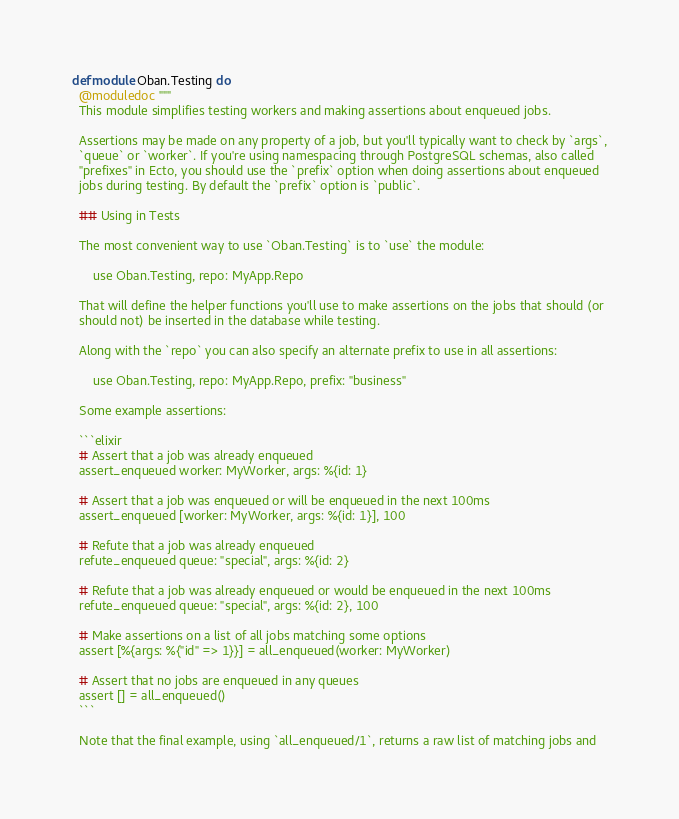Convert code to text. <code><loc_0><loc_0><loc_500><loc_500><_Elixir_>defmodule Oban.Testing do
  @moduledoc """
  This module simplifies testing workers and making assertions about enqueued jobs.

  Assertions may be made on any property of a job, but you'll typically want to check by `args`,
  `queue` or `worker`. If you're using namespacing through PostgreSQL schemas, also called
  "prefixes" in Ecto, you should use the `prefix` option when doing assertions about enqueued
  jobs during testing. By default the `prefix` option is `public`.

  ## Using in Tests

  The most convenient way to use `Oban.Testing` is to `use` the module:

      use Oban.Testing, repo: MyApp.Repo

  That will define the helper functions you'll use to make assertions on the jobs that should (or
  should not) be inserted in the database while testing.

  Along with the `repo` you can also specify an alternate prefix to use in all assertions:

      use Oban.Testing, repo: MyApp.Repo, prefix: "business"

  Some example assertions:

  ```elixir
  # Assert that a job was already enqueued
  assert_enqueued worker: MyWorker, args: %{id: 1}

  # Assert that a job was enqueued or will be enqueued in the next 100ms
  assert_enqueued [worker: MyWorker, args: %{id: 1}], 100

  # Refute that a job was already enqueued
  refute_enqueued queue: "special", args: %{id: 2}

  # Refute that a job was already enqueued or would be enqueued in the next 100ms
  refute_enqueued queue: "special", args: %{id: 2}, 100

  # Make assertions on a list of all jobs matching some options
  assert [%{args: %{"id" => 1}}] = all_enqueued(worker: MyWorker)

  # Assert that no jobs are enqueued in any queues
  assert [] = all_enqueued()
  ```

  Note that the final example, using `all_enqueued/1`, returns a raw list of matching jobs and</code> 